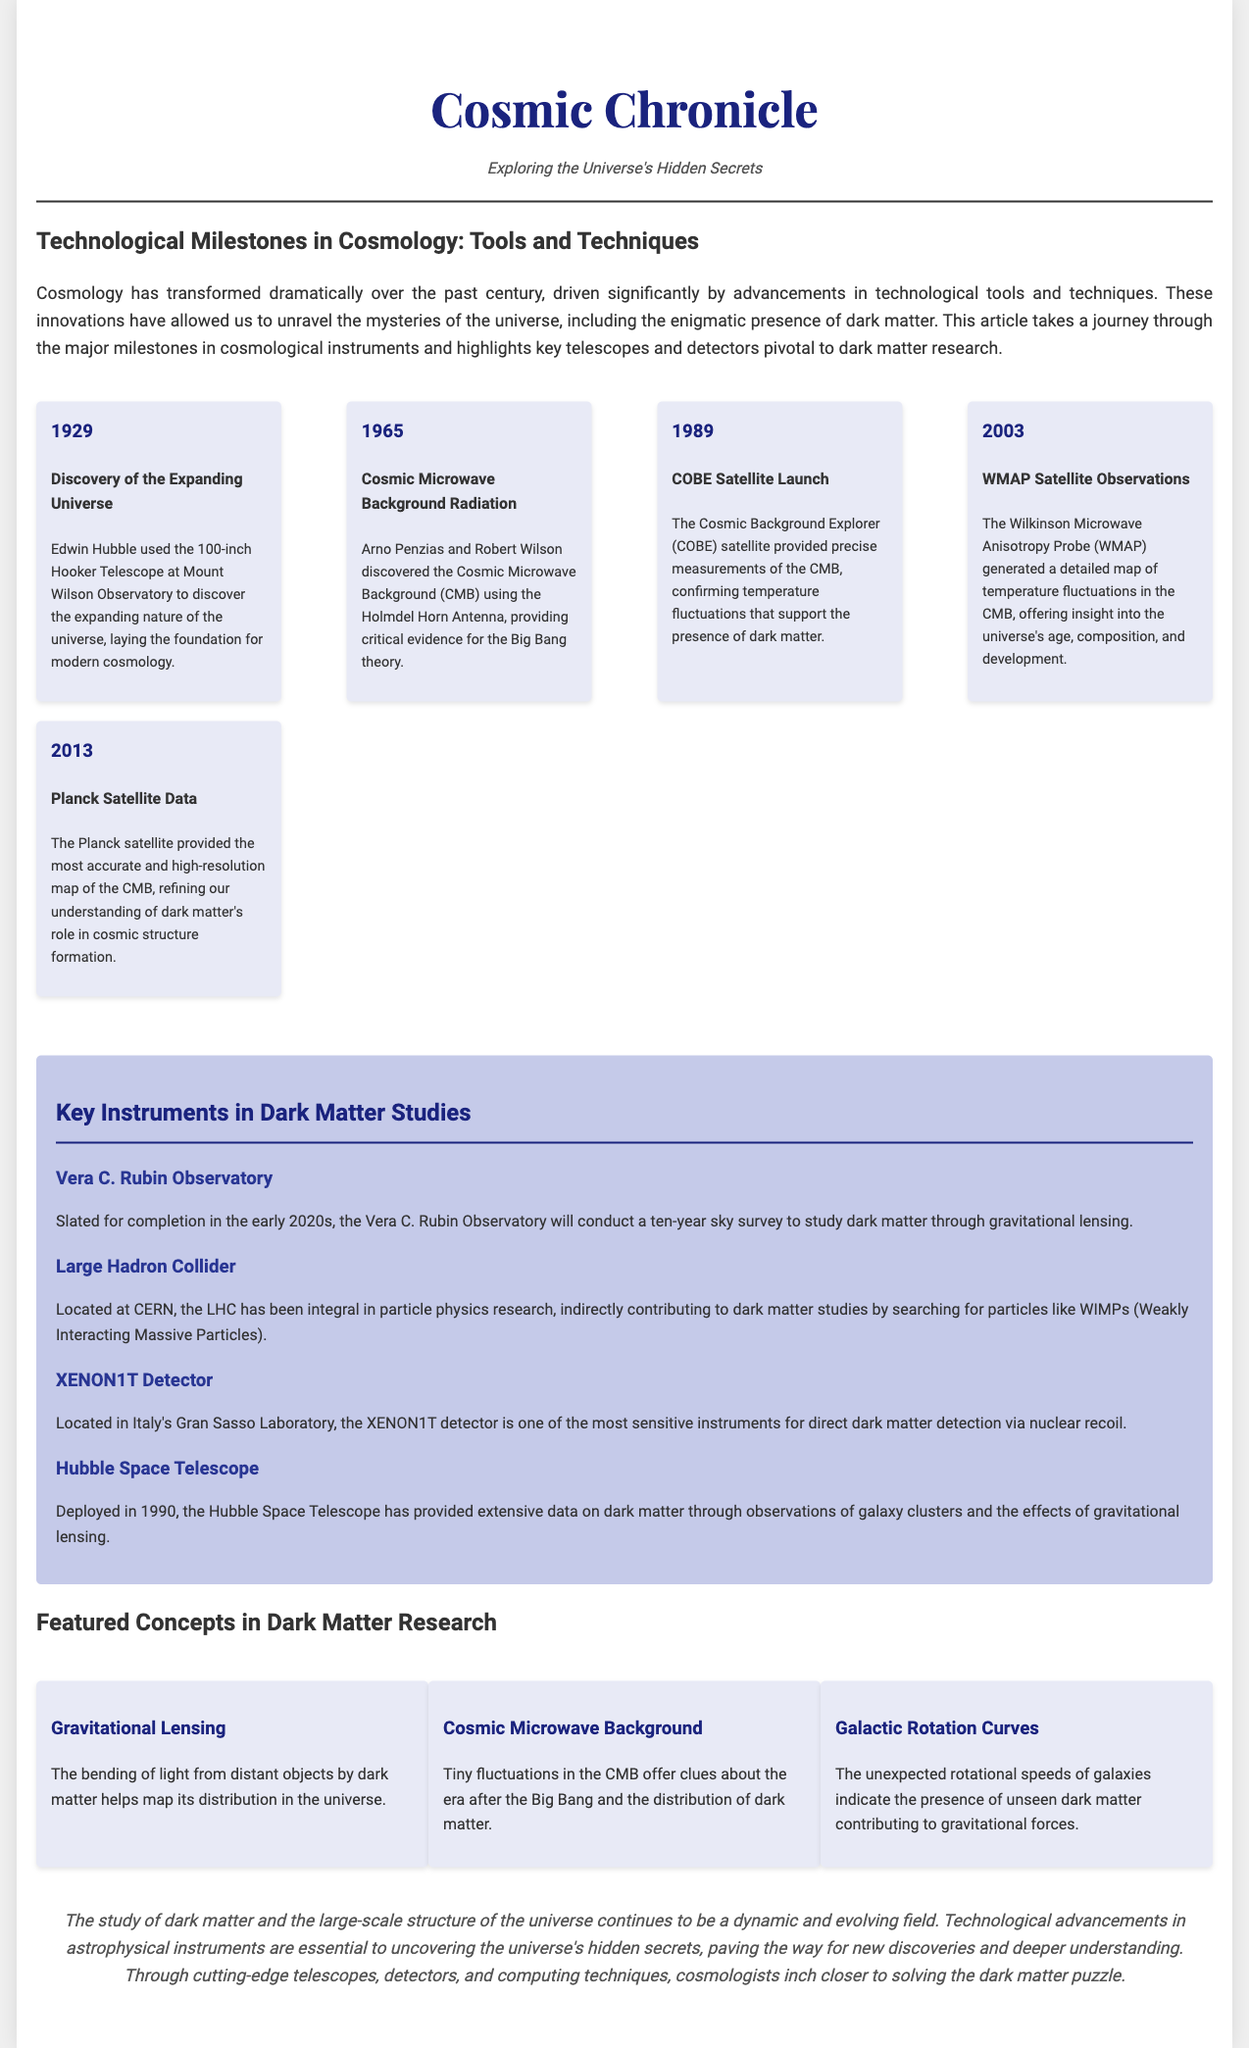What significant discovery did Edwin Hubble make in 1929? Edwin Hubble discovered the expanding nature of the universe using the 100-inch Hooker Telescope.
Answer: Expanding universe What tool was used to discover the Cosmic Microwave Background Radiation in 1965? The Holmdel Horn Antenna was used to discover the Cosmic Microwave Background Radiation.
Answer: Holmdel Horn Antenna Which satellite provided accurate measurements of the CMB and confirmed dark matter's presence in 1989? The Cosmic Background Explorer (COBE) satellite provided critical measurements of the CMB.
Answer: COBE Satellite What is the purpose of the Vera C. Rubin Observatory? The Vera C. Rubin Observatory will conduct a ten-year sky survey to study dark matter through gravitational lensing.
Answer: Study dark matter Which concept refers to the bending of light by dark matter? The bending of light from distant objects by dark matter is known as gravitational lensing.
Answer: Gravitational lensing What type of research has the Large Hadron Collider (LHC) contributed to? The LHC has indirectly contributed to dark matter studies by searching for particles like WIMPs.
Answer: Particle physics research What year was the Hubble Space Telescope deployed? The Hubble Space Telescope was deployed in 1990.
Answer: 1990 What advanced technique maps the distribution of dark matter in galaxies? The unexpected rotational speeds of galaxies indicate the presence of unseen dark matter contributing to gravitational forces.
Answer: Galactic Rotation Curves 